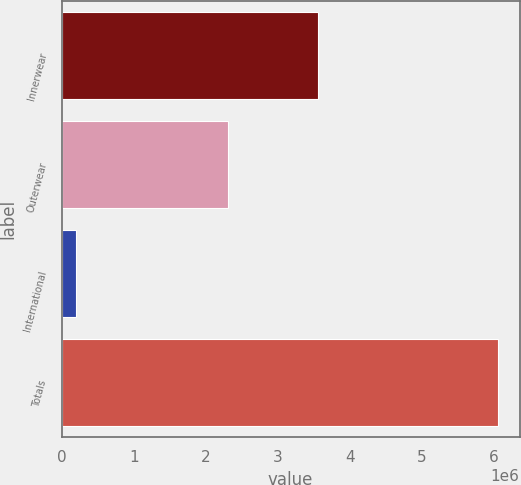Convert chart to OTSL. <chart><loc_0><loc_0><loc_500><loc_500><bar_chart><fcel>Innerwear<fcel>Outerwear<fcel>International<fcel>Totals<nl><fcel>3.55718e+06<fcel>2.30915e+06<fcel>191793<fcel>6.05813e+06<nl></chart> 